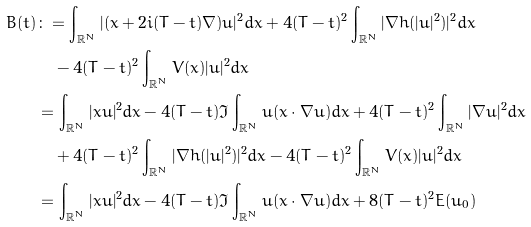Convert formula to latex. <formula><loc_0><loc_0><loc_500><loc_500>B ( t ) & \colon = \int _ { \mathbb { R } ^ { N } } | ( x + 2 i ( T - t ) \nabla ) u | ^ { 2 } d x + 4 ( T - t ) ^ { 2 } \int _ { \mathbb { R } ^ { N } } | \nabla h ( | u | ^ { 2 } ) | ^ { 2 } d x \\ & \quad - 4 ( T - t ) ^ { 2 } \int _ { \mathbb { R } ^ { N } } V ( x ) | u | ^ { 2 } d x \\ & = \int _ { \mathbb { R } ^ { N } } | x u | ^ { 2 } d x - 4 ( T - t ) \Im \int _ { \mathbb { R } ^ { N } } \bar { u } ( x \cdot \nabla u ) d x + 4 ( T - t ) ^ { 2 } \int _ { \mathbb { R } ^ { N } } | \nabla u | ^ { 2 } d x \\ & \quad + 4 ( T - t ) ^ { 2 } \int _ { \mathbb { R } ^ { N } } | \nabla h ( | u | ^ { 2 } ) | ^ { 2 } d x - 4 ( T - t ) ^ { 2 } \int _ { \mathbb { R } ^ { N } } V ( x ) | u | ^ { 2 } d x \\ & = \int _ { \mathbb { R } ^ { N } } | x u | ^ { 2 } d x - 4 ( T - t ) \Im \int _ { \mathbb { R } ^ { N } } \bar { u } ( x \cdot \nabla u ) d x + 8 ( T - t ) ^ { 2 } E ( u _ { 0 } )</formula> 